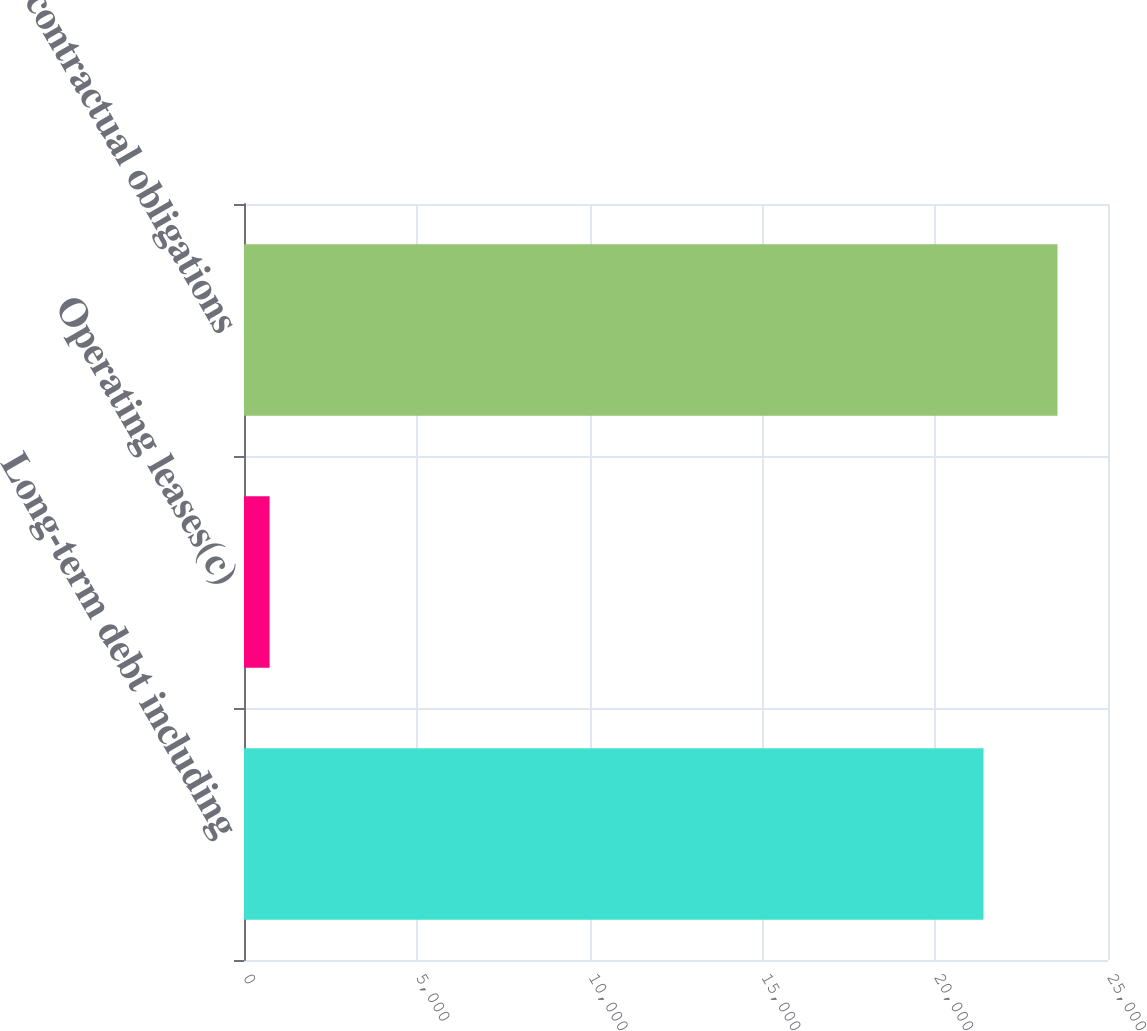Convert chart. <chart><loc_0><loc_0><loc_500><loc_500><bar_chart><fcel>Long-term debt including<fcel>Operating leases(c)<fcel>Total contractual obligations<nl><fcel>21398<fcel>740<fcel>23537.8<nl></chart> 